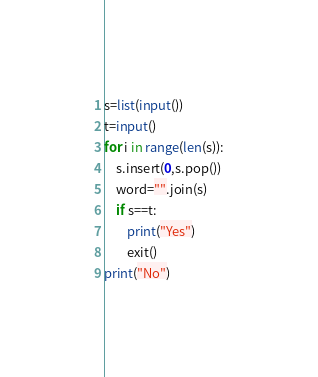Convert code to text. <code><loc_0><loc_0><loc_500><loc_500><_Python_>s=list(input())
t=input()
for i in range(len(s)):
    s.insert(0,s.pop())
    word="".join(s)
    if s==t:
        print("Yes")
        exit()
print("No")</code> 